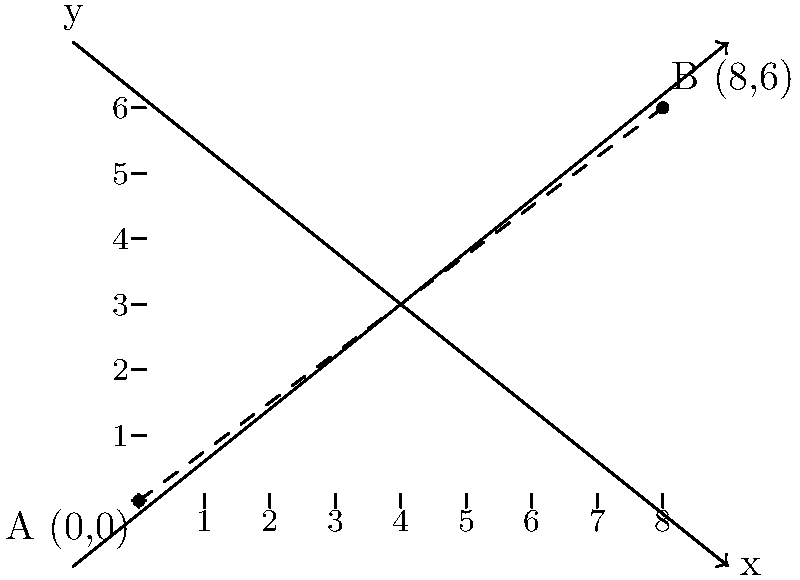In a study on the impact of incarceration on families, point A (0,0) represents an incarcerated individual, and point B (8,6) represents their family member. If each unit on the coordinate plane represents 10 miles, what is the straight-line distance between the incarcerated individual and their family member? To find the distance between two points on a coordinate plane, we can use the distance formula:

$$d = \sqrt{(x_2 - x_1)^2 + (y_2 - y_1)^2}$$

Where $(x_1, y_1)$ are the coordinates of the first point and $(x_2, y_2)$ are the coordinates of the second point.

Given:
Point A (incarcerated individual): $(0, 0)$
Point B (family member): $(8, 6)$

Let's plug these values into the formula:

$$d = \sqrt{(8 - 0)^2 + (6 - 0)^2}$$

Simplify:
$$d = \sqrt{8^2 + 6^2}$$
$$d = \sqrt{64 + 36}$$
$$d = \sqrt{100}$$
$$d = 10$$

This gives us the distance in units on the coordinate plane. Since each unit represents 10 miles, we multiply the result by 10:

$$10 \times 10 \text{ miles} = 100 \text{ miles}$$

Therefore, the straight-line distance between the incarcerated individual and their family member is 100 miles.
Answer: 100 miles 